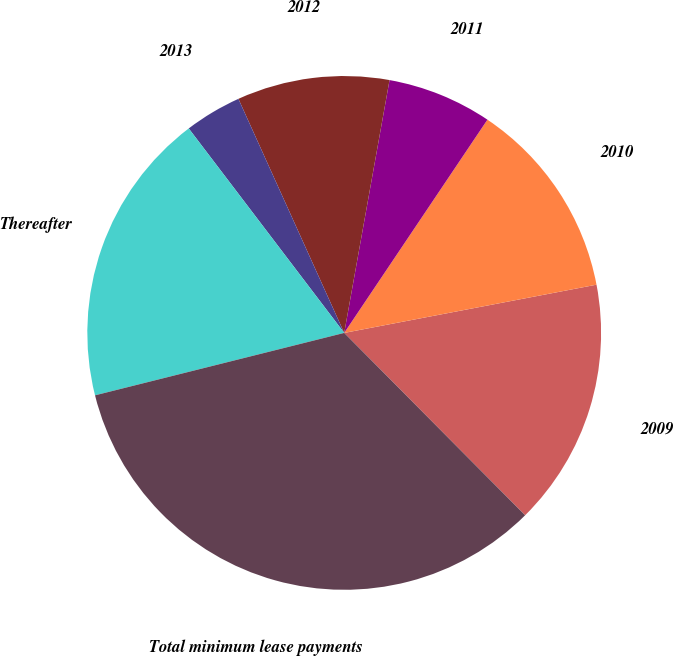Convert chart to OTSL. <chart><loc_0><loc_0><loc_500><loc_500><pie_chart><fcel>2009<fcel>2010<fcel>2011<fcel>2012<fcel>2013<fcel>Thereafter<fcel>Total minimum lease payments<nl><fcel>15.57%<fcel>12.58%<fcel>6.59%<fcel>9.58%<fcel>3.59%<fcel>18.56%<fcel>33.53%<nl></chart> 